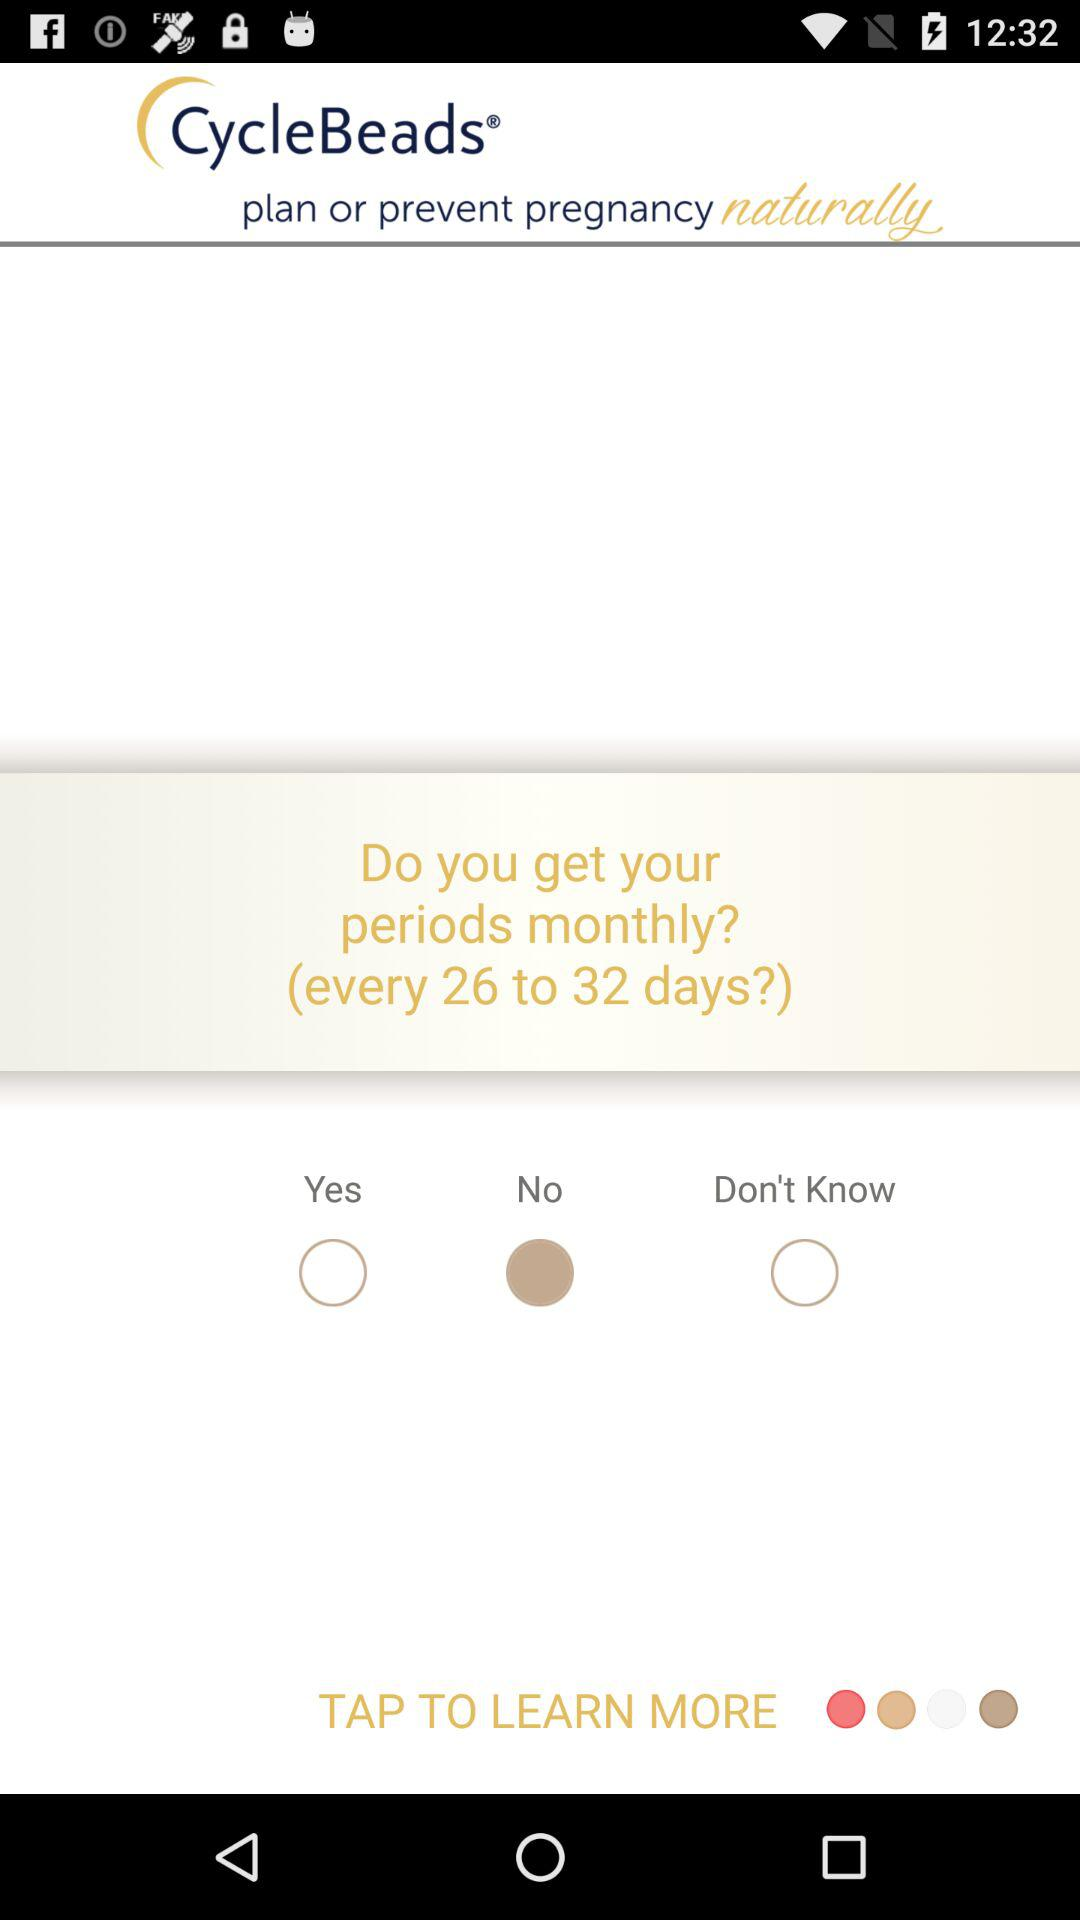What is the name of the application? The name of the application is "CycleBeads". 